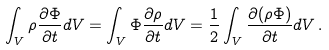Convert formula to latex. <formula><loc_0><loc_0><loc_500><loc_500>\int _ { V } \rho \frac { \partial \Phi } { \partial t } d V = \int _ { V } \Phi \frac { \partial \rho } { \partial t } d V = \frac { 1 } { 2 } \int _ { V } \frac { \partial ( \rho \Phi ) } { \partial t } d V \, .</formula> 